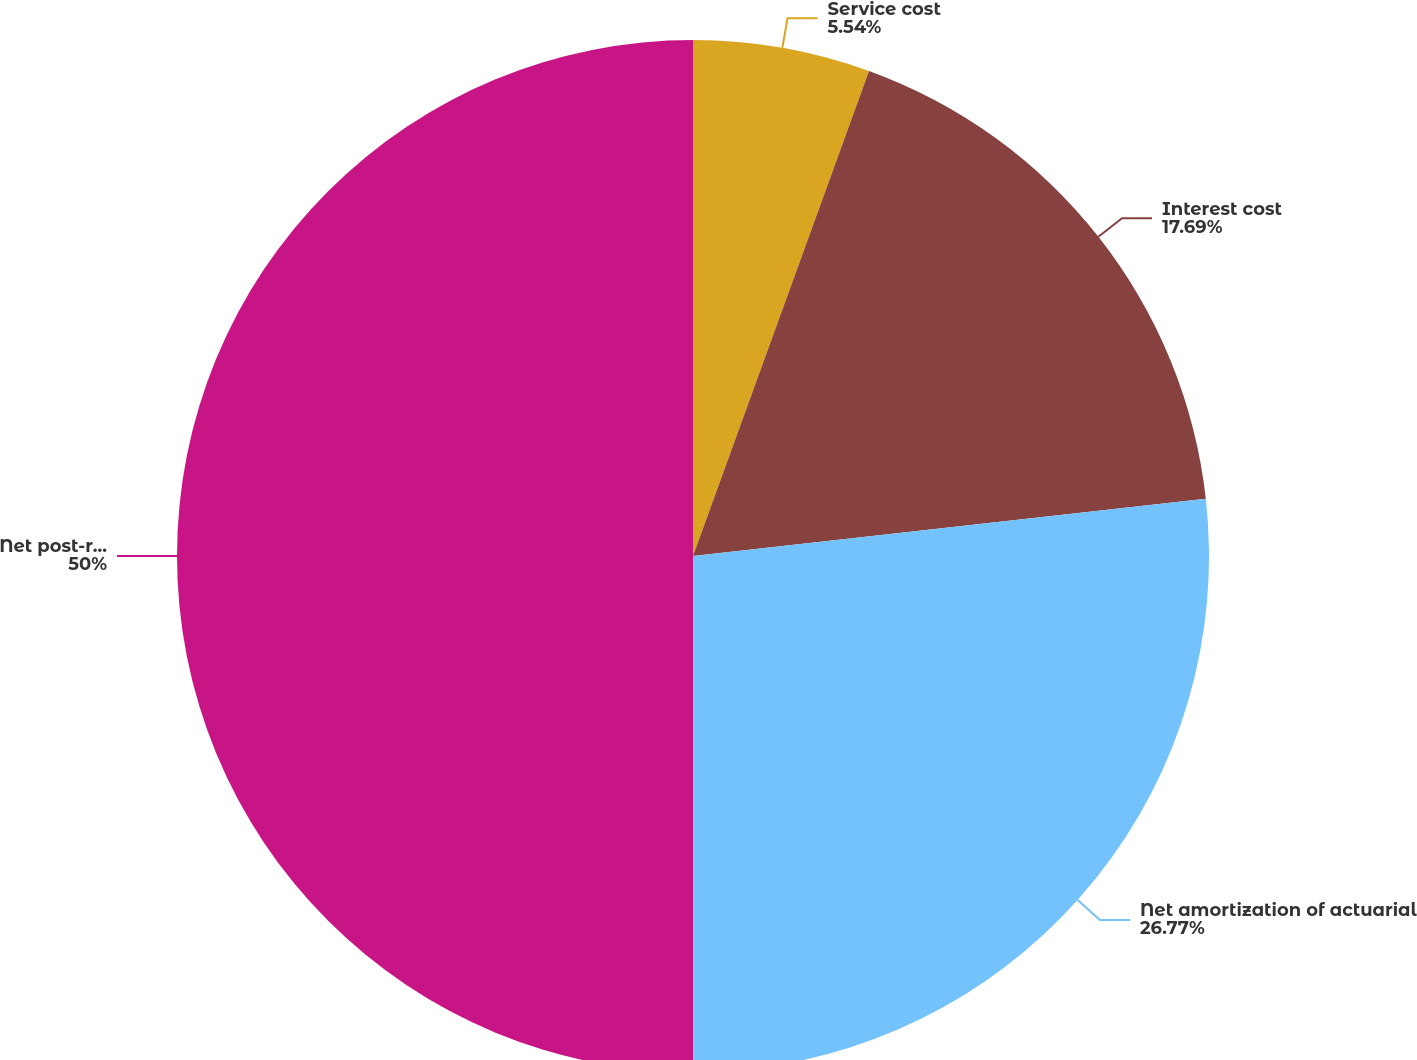Convert chart. <chart><loc_0><loc_0><loc_500><loc_500><pie_chart><fcel>Service cost<fcel>Interest cost<fcel>Net amortization of actuarial<fcel>Net post-retirement benefit<nl><fcel>5.54%<fcel>17.69%<fcel>26.77%<fcel>50.0%<nl></chart> 